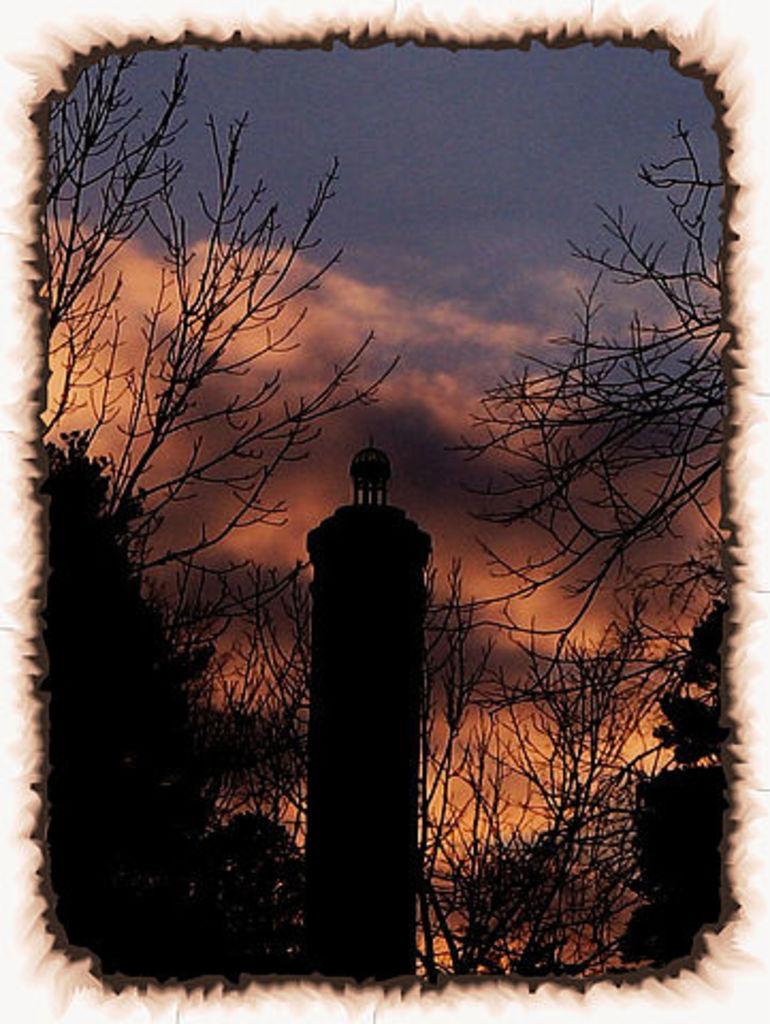In one or two sentences, can you explain what this image depicts? This is an edited image. In the center of the image there is a tower. There are trees. In the background of the image there are clouds and sky. 